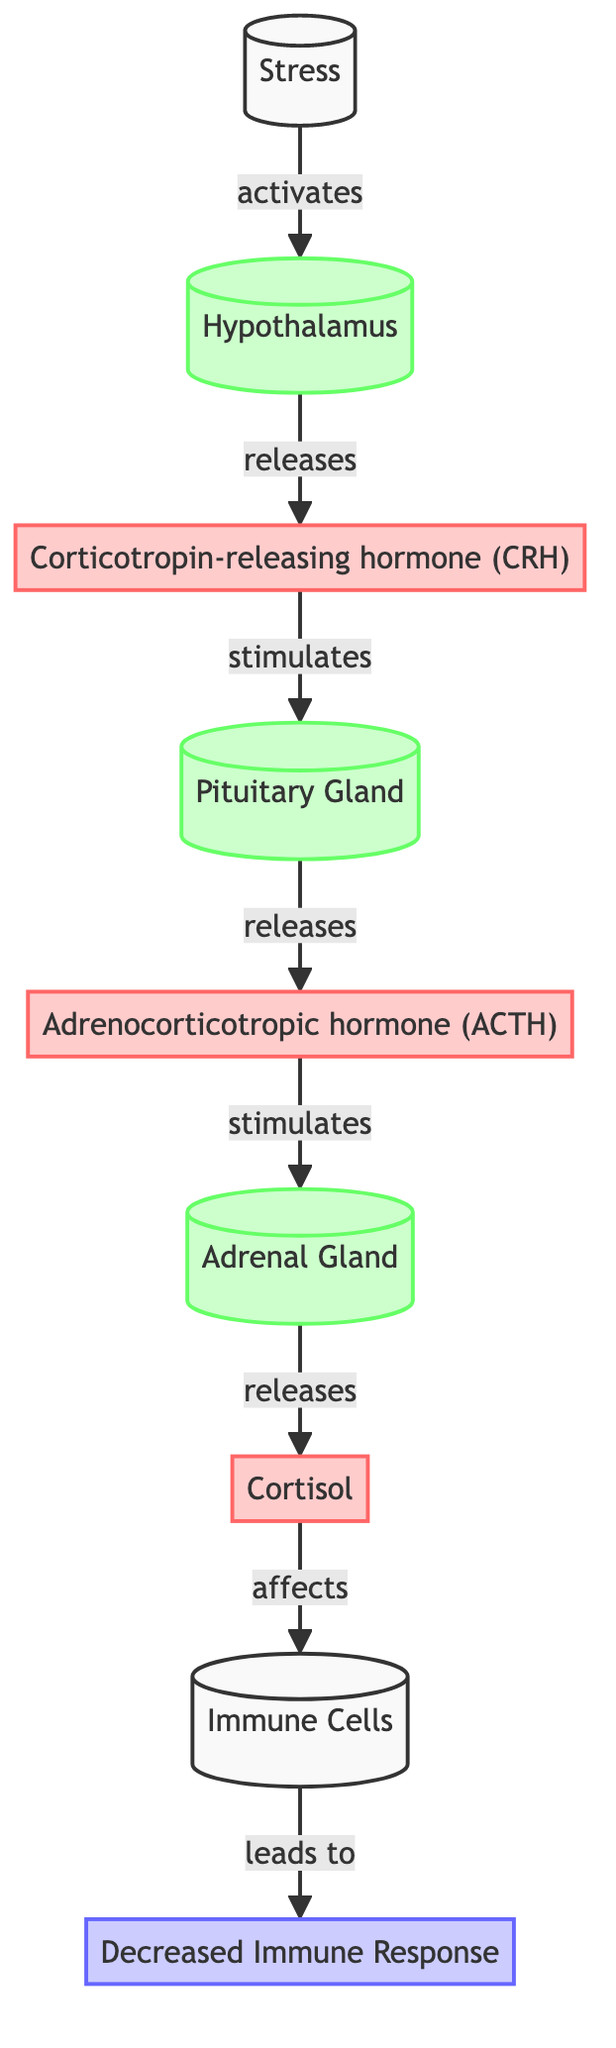How many glands are present in the diagram? The diagram lists three glands: the hypothalamus, pituitary gland, and adrenal gland. Therefore, by counting these nodes, we determine that there are three glands in total.
Answer: 3 What hormone is released by the pituitary gland? The diagram indicates that the pituitary gland releases "Adrenocorticotropic hormone (ACTH)." This information can be found directly in the node connected to the pituitary gland.
Answer: Adrenocorticotropic hormone (ACTH) Which hormone is primarily affected by stress? The diagram shows that stress activates the hypothalamus, which leads to the release of cortisol from the adrenal gland. Therefore, cortisol is the hormone primarily affected by stress.
Answer: Cortisol What is the result of cortisol's effect on immune cells? According to the diagram, cortisol affects immune cells, which leads to a "Decreased Immune Response." This flow indicates that the impacts of cortisol on immune function are negative, resulting in a weakened immune response.
Answer: Decreased Immune Response What sequence of events follows the activation of the hypothalamus? The sequence is: stress activates the hypothalamus, which releases corticotropin-releasing hormone (CRH), stimulating the pituitary gland to release adrenocorticotropic hormone (ACTH), leading to the adrenal gland, which releases cortisol. This logical flow from one gland to another highlights the biochemical process triggered by stress.
Answer: Stress activates hypothalamus, releases CRH, stimulates pituitary, releases ACTH, stimulates adrenal, releases cortisol 